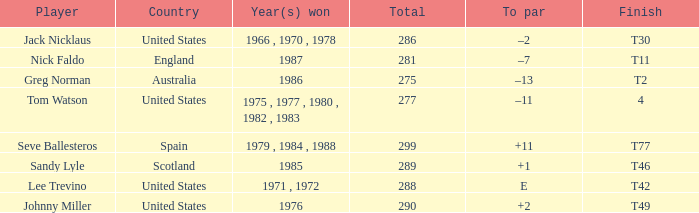What's the finish for the total 288? T42. 